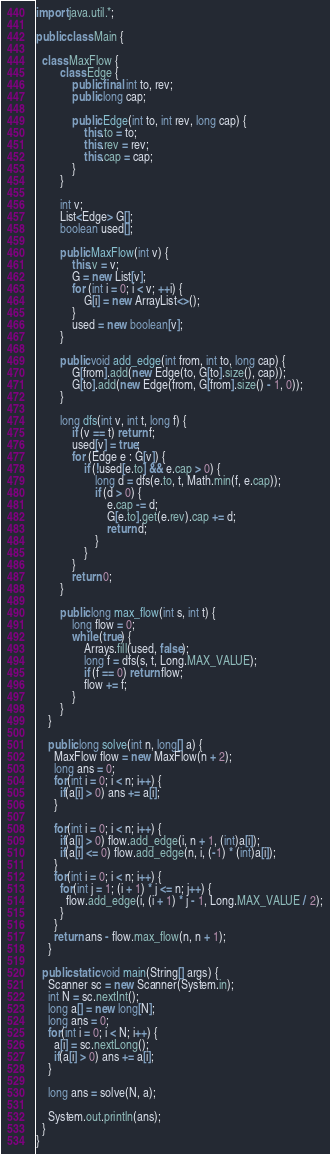Convert code to text. <code><loc_0><loc_0><loc_500><loc_500><_Java_>import java.util.*;

public class Main {

  class MaxFlow {
        class Edge {
            public final int to, rev;
            public long cap;
 
            public Edge(int to, int rev, long cap) {
                this.to = to;
                this.rev = rev;
                this.cap = cap;
            }
        }
 
        int v;
        List<Edge> G[];
        boolean used[];
 
        public MaxFlow(int v) {
            this.v = v;
            G = new List[v];
            for (int i = 0; i < v; ++i) {
                G[i] = new ArrayList<>();
            }
            used = new boolean[v];
        }
 
        public void add_edge(int from, int to, long cap) {
            G[from].add(new Edge(to, G[to].size(), cap));
            G[to].add(new Edge(from, G[from].size() - 1, 0));
        }
 
        long dfs(int v, int t, long f) {
            if (v == t) return f;
            used[v] = true;
            for (Edge e : G[v]) {
                if (!used[e.to] && e.cap > 0) {
                    long d = dfs(e.to, t, Math.min(f, e.cap));
                    if (d > 0) {
                        e.cap -= d;
                        G[e.to].get(e.rev).cap += d;
                        return d;
                    }
                }
            }
            return 0;
        }
 
        public long max_flow(int s, int t) {
            long flow = 0;
            while (true) {
                Arrays.fill(used, false);
                long f = dfs(s, t, Long.MAX_VALUE);
                if (f == 0) return flow;
                flow += f;
            }
        }
    }

    public long solve(int n, long[] a) {
      MaxFlow flow = new MaxFlow(n + 2);
      long ans = 0;
      for(int i = 0; i < n; i++) {
        if(a[i] > 0) ans += a[i];
      }

      for(int i = 0; i < n; i++) {
        if(a[i] > 0) flow.add_edge(i, n + 1, (int)a[i]);
        if(a[i] <= 0) flow.add_edge(n, i, (-1) * (int)a[i]);
      }
      for(int i = 0; i < n; i++) {
        for(int j = 1; (i + 1) * j <= n; j++) {
          flow.add_edge(i, (i + 1) * j - 1, Long.MAX_VALUE / 2);
        }
      }
      return ans - flow.max_flow(n, n + 1);
    }

  public static void main(String[] args) {
    Scanner sc = new Scanner(System.in);
    int N = sc.nextInt();
    long a[] = new long[N];
    long ans = 0;
    for(int i = 0; i < N; i++) {
      a[i] = sc.nextLong();
      if(a[i] > 0) ans += a[i];
    }

    long ans = solve(N, a);

    System.out.println(ans);
  }
}</code> 